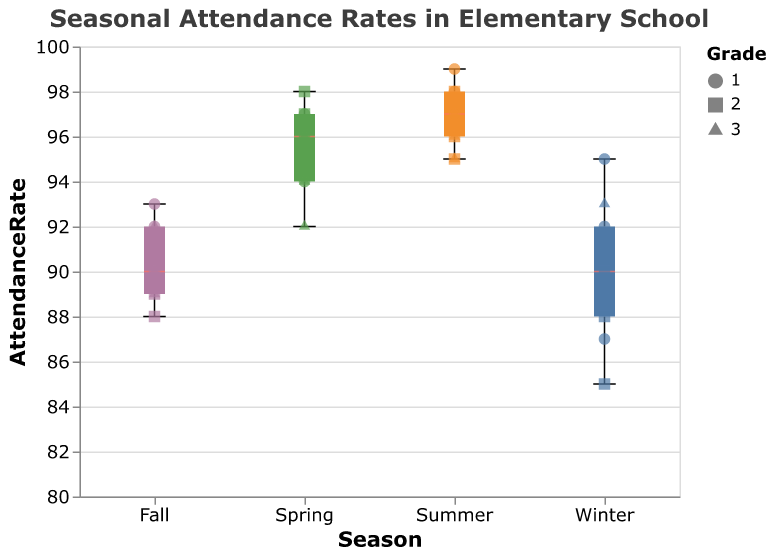What's the title of the chart? The title of the chart is displayed at the top of the figure and it reads: "Seasonal Attendance Rates in Elementary School".
Answer: Seasonal Attendance Rates in Elementary School Which season has the highest median attendance rate? By looking at the boxplots, the median line inside the box for each season shows that Summer has the highest median attendance rate compared to Winter, Spring, and Fall.
Answer: Summer How many attendance rate data points are there for Grade 1 in Winter? The scatter points for Winter colored accordingly show three distinct points labeled with shapes corresponding to Grade 1.
Answer: 3 What shape represents Grade 3 in the scatter plot points? The legend and scatter points show that the triangle shape is used for representing Grade 3 students.
Answer: Triangle Which season shows the widest range of attendance rates? The length of the boxes (from the minimum to maximum whiskers) shows the range of attendance rates. Winter has the widest range compared to Spring, Summer, and Fall.
Answer: Winter What is the median attendance rate in Spring for Grade 2? The median, indicated by the central line in the box for Spring, is around 97. Grade 2 points in Spring also cluster around this value.
Answer: 97 Compare the median attendance rates between Winter and Fall. Which one is higher? The median line inside the box for Winter is lower than the median line for Fall, indicating that Fall has a higher median attendance rate.
Answer: Fall What is the highest attendance rate recorded in any season for Grade 1? By looking at the scatter points for Grade 1 (circle shapes), the highest point is in Summer with an attendance rate of 99.
Answer: 99 Which grade shows a decline in attendance rate as the seasons progress from Winter to Fall? By observing the scatter points for each grade, Grade 3 (triangle shapes) tends to show a slight decline in attendance rates from Winter to Fall.
Answer: Grade 3 What is the interquartile range (IQR) for student attendance rates in Fall? The IQR is the difference between the upper quartile and lower quartile. In Fall, the upper quartile is about 92, and the lower quartile is about 89, giving an IQR of 92 - 89.
Answer: 3 